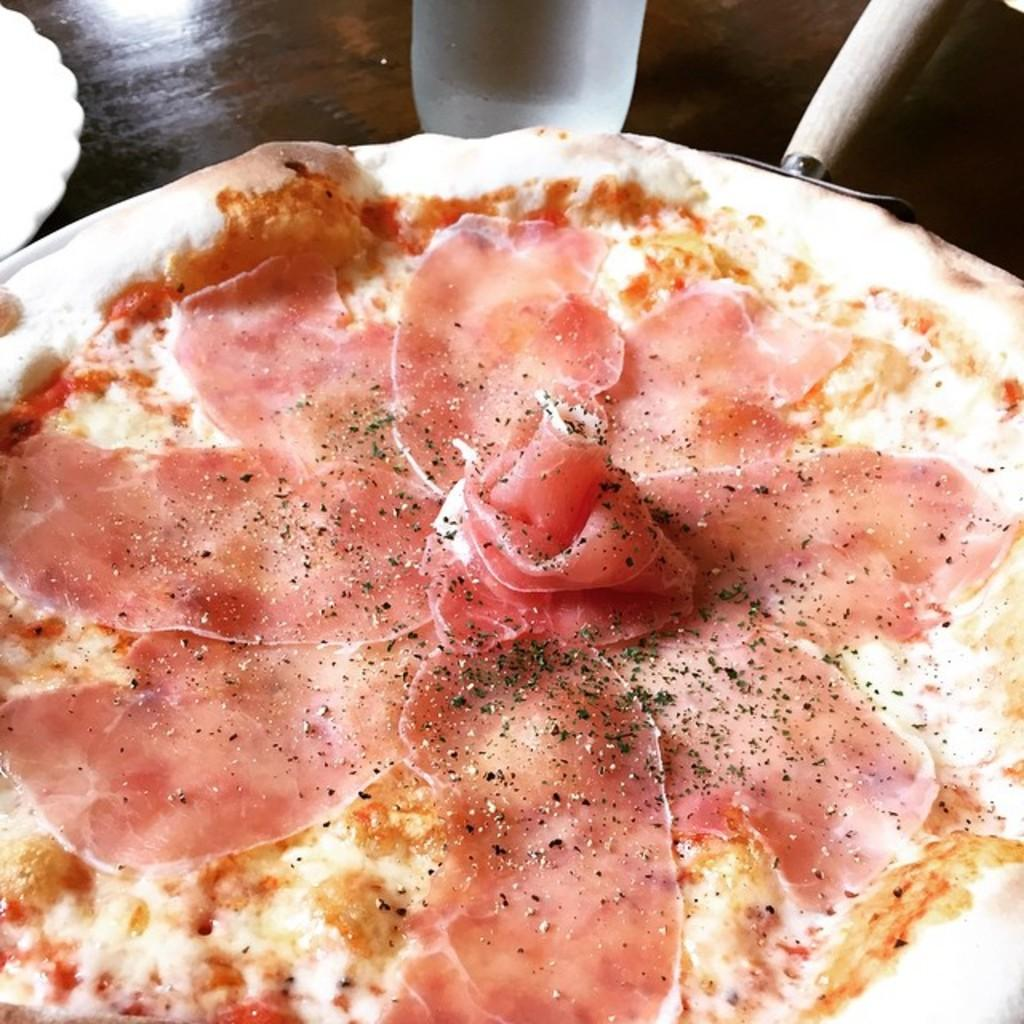What is the main food item in the image? There is a pizza in the image. What can be seen on top of the pizza? There are food items on the pizza. What type of seasoning is present on the pizza? Pepper powder is present on the pizza. Can you describe the white color object in the image? Unfortunately, there is no information provided about a white color object in the image. What type of cloth is draped over the chair in the image? There is no chair or cloth present in the image. 